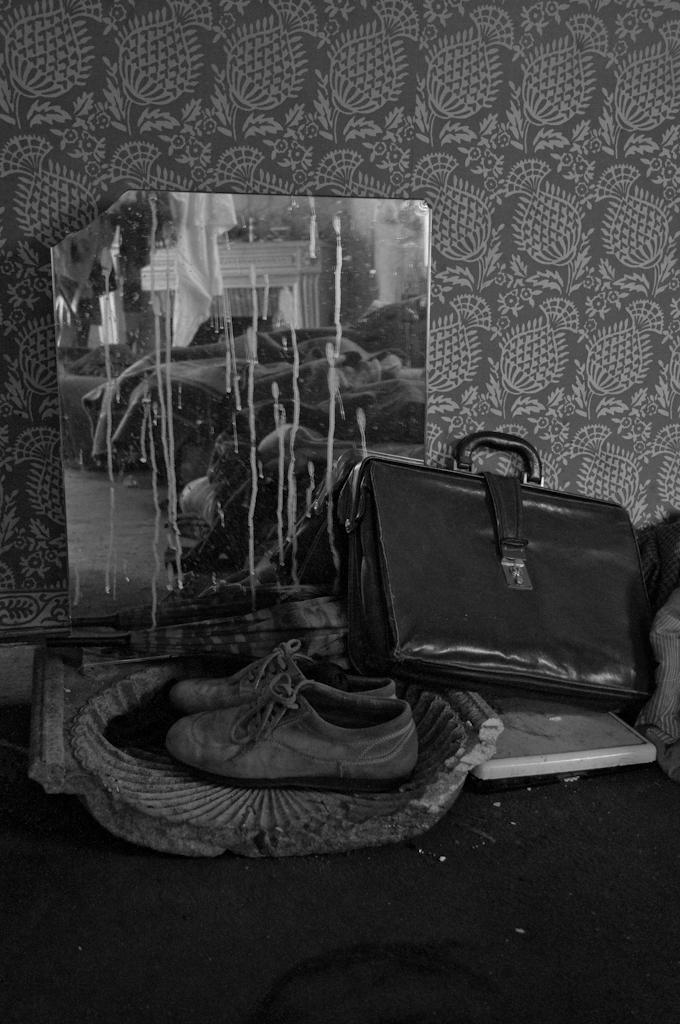How would you summarize this image in a sentence or two? This picture shows a pair of shoes and a bag and a poster on the floor. 